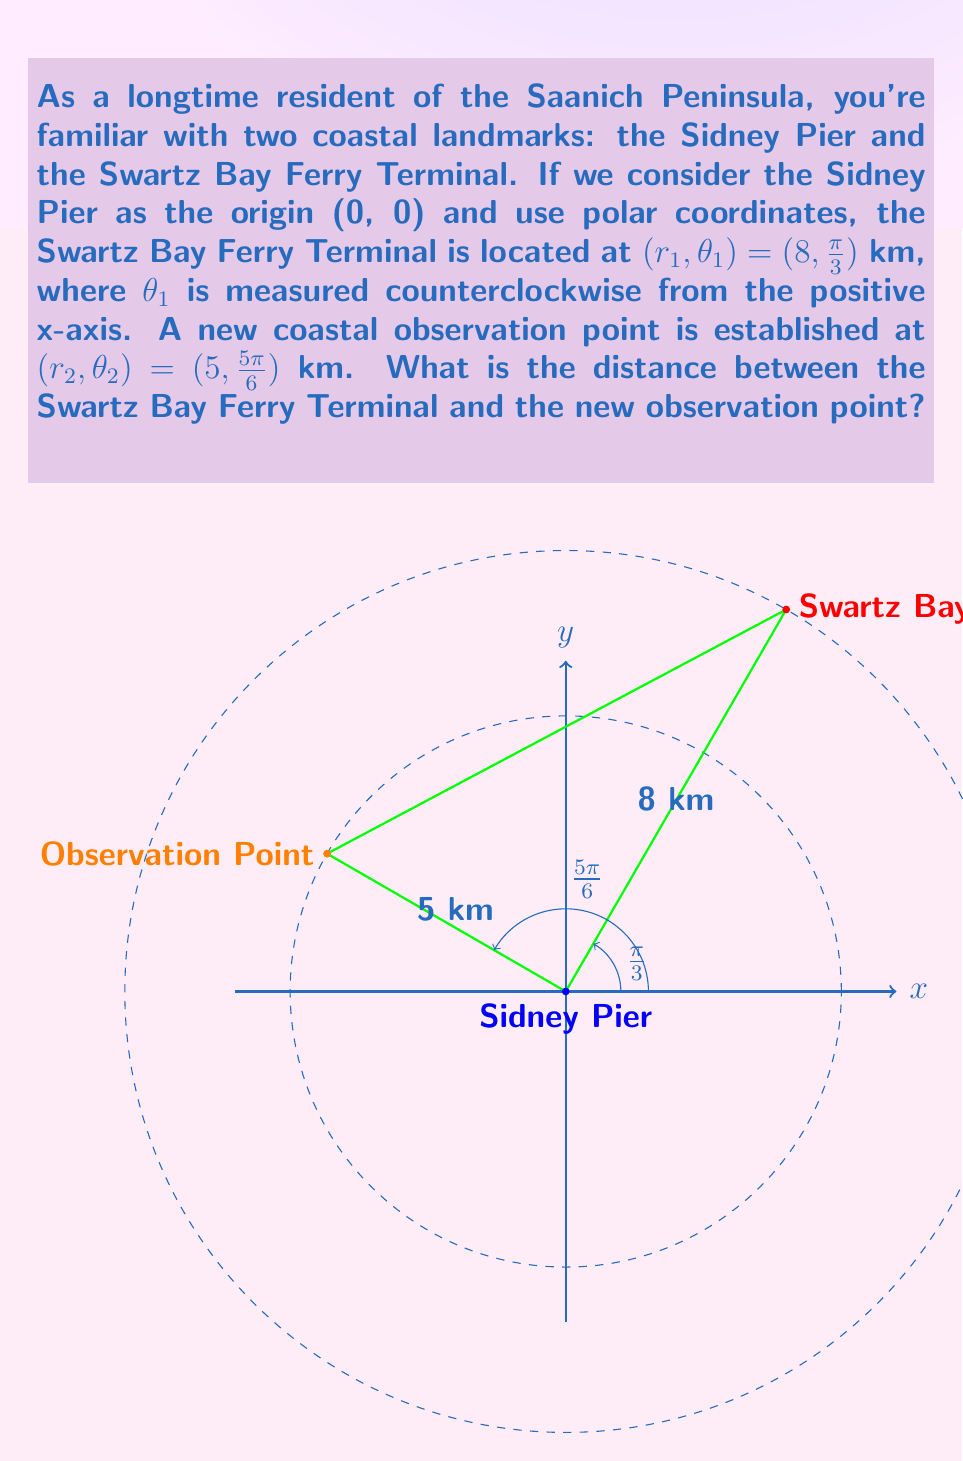Can you solve this math problem? To find the distance between two points in polar form, we can use the polar form of the distance formula:

$$d = \sqrt{r_1^2 + r_2^2 - 2r_1r_2\cos(\theta_2 - \theta_1)}$$

Where $(r_1, \theta_1)$ and $(r_2, \theta_2)$ are the polar coordinates of the two points.

Let's substitute the given values:
$r_1 = 8$ km, $\theta_1 = \frac{\pi}{3}$
$r_2 = 5$ km, $\theta_2 = \frac{5\pi}{6}$

First, calculate $\theta_2 - \theta_1$:
$$\theta_2 - \theta_1 = \frac{5\pi}{6} - \frac{\pi}{3} = \frac{5\pi}{6} - \frac{2\pi}{6} = \frac{3\pi}{6} = \frac{\pi}{2}$$

Now, let's substitute these values into the distance formula:

$$\begin{align}
d &= \sqrt{8^2 + 5^2 - 2(8)(5)\cos(\frac{\pi}{2})} \\
&= \sqrt{64 + 25 - 80\cos(\frac{\pi}{2})} \\
&= \sqrt{64 + 25 - 80(0)} \quad \text{(since $\cos(\frac{\pi}{2}) = 0$)} \\
&= \sqrt{64 + 25} \\
&= \sqrt{89} \\
&\approx 9.43 \text{ km}
\end{align}$$

Therefore, the distance between the Swartz Bay Ferry Terminal and the new observation point is approximately 9.43 km.
Answer: $\sqrt{89}$ km $\approx 9.43$ km 